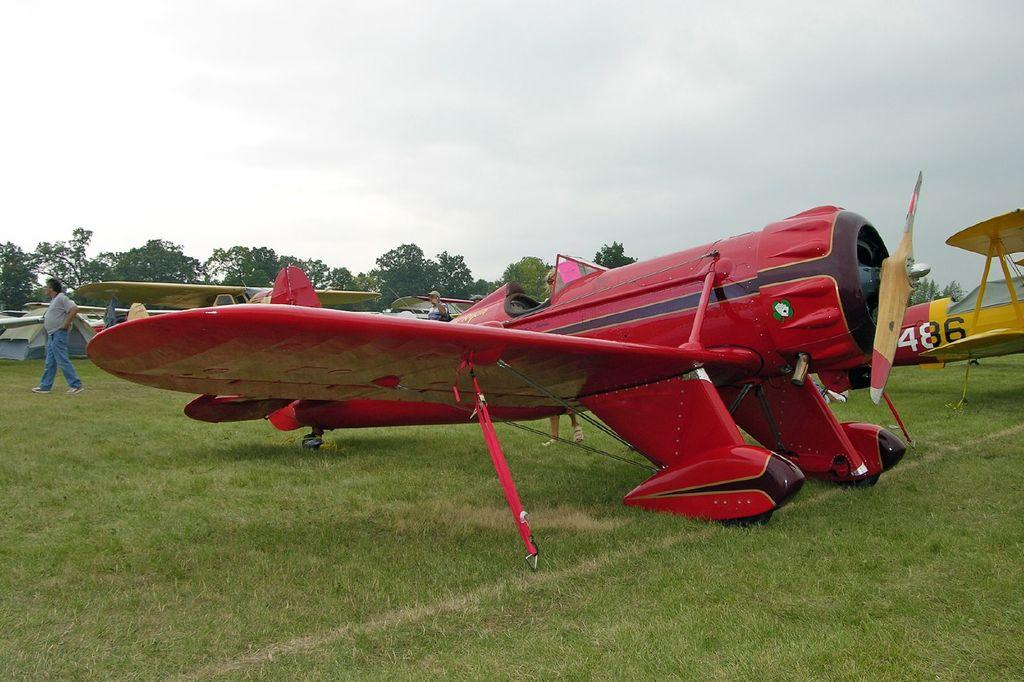<image>
Relay a brief, clear account of the picture shown. A row of propeller planes, one with the marking 486 on it's side. 